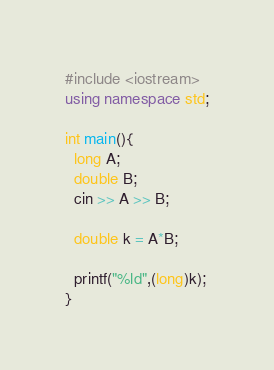Convert code to text. <code><loc_0><loc_0><loc_500><loc_500><_C++_>#include <iostream>
using namespace std;

int main(){
  long A;
  double B;
  cin >> A >> B;

  double k = A*B;

  printf("%ld",(long)k);
}
</code> 